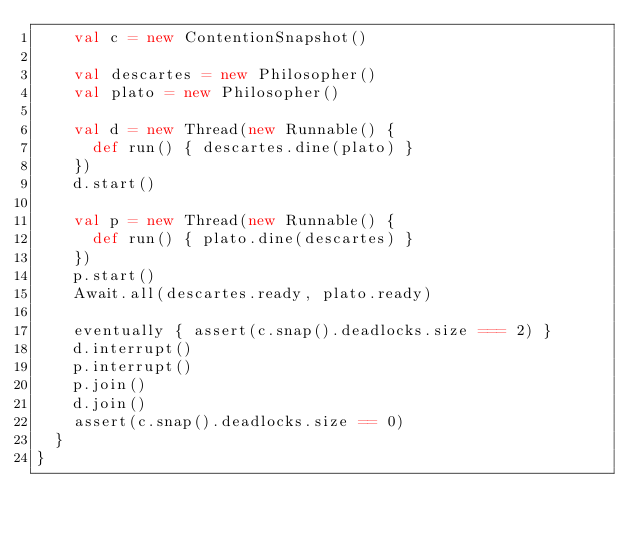Convert code to text. <code><loc_0><loc_0><loc_500><loc_500><_Scala_>    val c = new ContentionSnapshot()

    val descartes = new Philosopher()
    val plato = new Philosopher()

    val d = new Thread(new Runnable() {
      def run() { descartes.dine(plato) }
    })
    d.start()

    val p = new Thread(new Runnable() {
      def run() { plato.dine(descartes) }
    })
    p.start()
    Await.all(descartes.ready, plato.ready)

    eventually { assert(c.snap().deadlocks.size === 2) }
    d.interrupt()
    p.interrupt()
    p.join()
    d.join()
    assert(c.snap().deadlocks.size == 0)
  }
}
</code> 